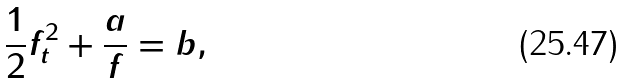Convert formula to latex. <formula><loc_0><loc_0><loc_500><loc_500>\frac { 1 } { 2 } f _ { t } ^ { 2 } + \frac { a } { f } = b ,</formula> 